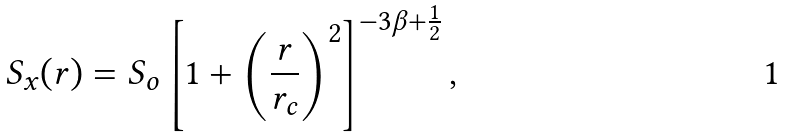Convert formula to latex. <formula><loc_0><loc_0><loc_500><loc_500>S _ { x } ( r ) = S _ { o } \left [ 1 + \left ( \frac { r } { r _ { c } } \right ) ^ { 2 } \right ] ^ { - 3 \beta + \frac { 1 } { 2 } } ,</formula> 